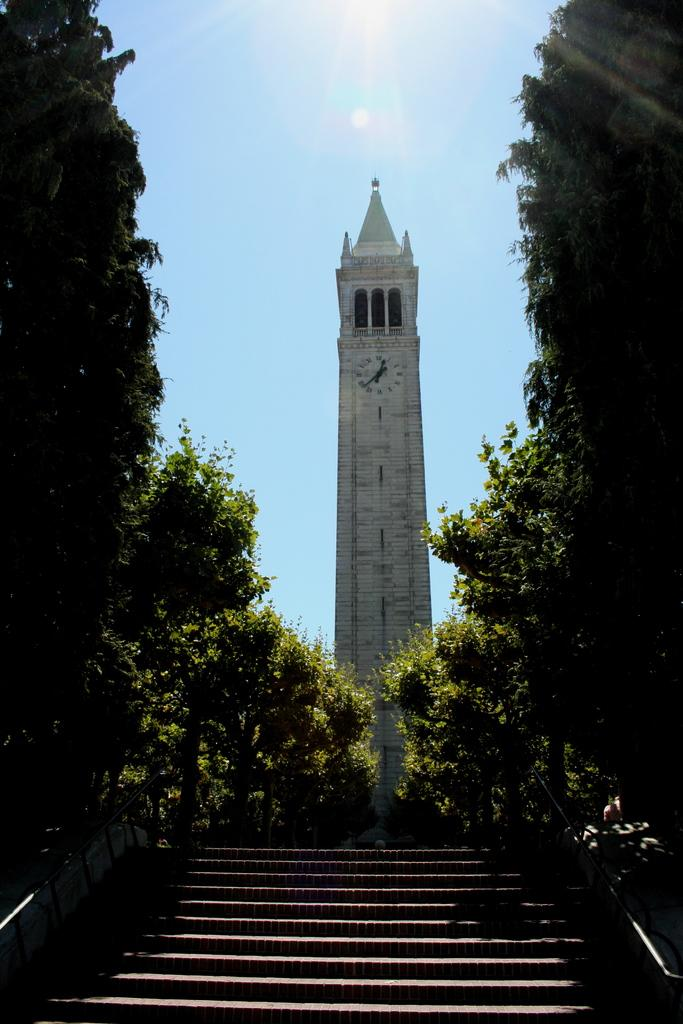What type of architectural feature can be seen in the image? There are steps in the image. What is the main structure in the image? There is a tower in the image. What type of vegetation is near the tower? There are trees beside the tower. What is on the tower in the image? There is a clock on the tower. Can you see a man holding a rifle in the image? There is no man or rifle present in the image. What type of war is depicted in the image? There is no war depicted in the image; it features a tower with a clock and trees. 